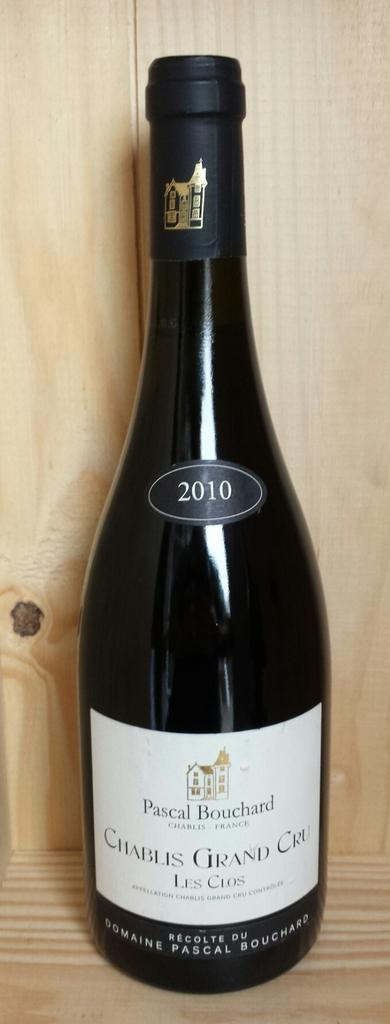<image>
Write a terse but informative summary of the picture. A dark bottle of Cablis Grand Cru, 2010 sitting on a wood platform. 